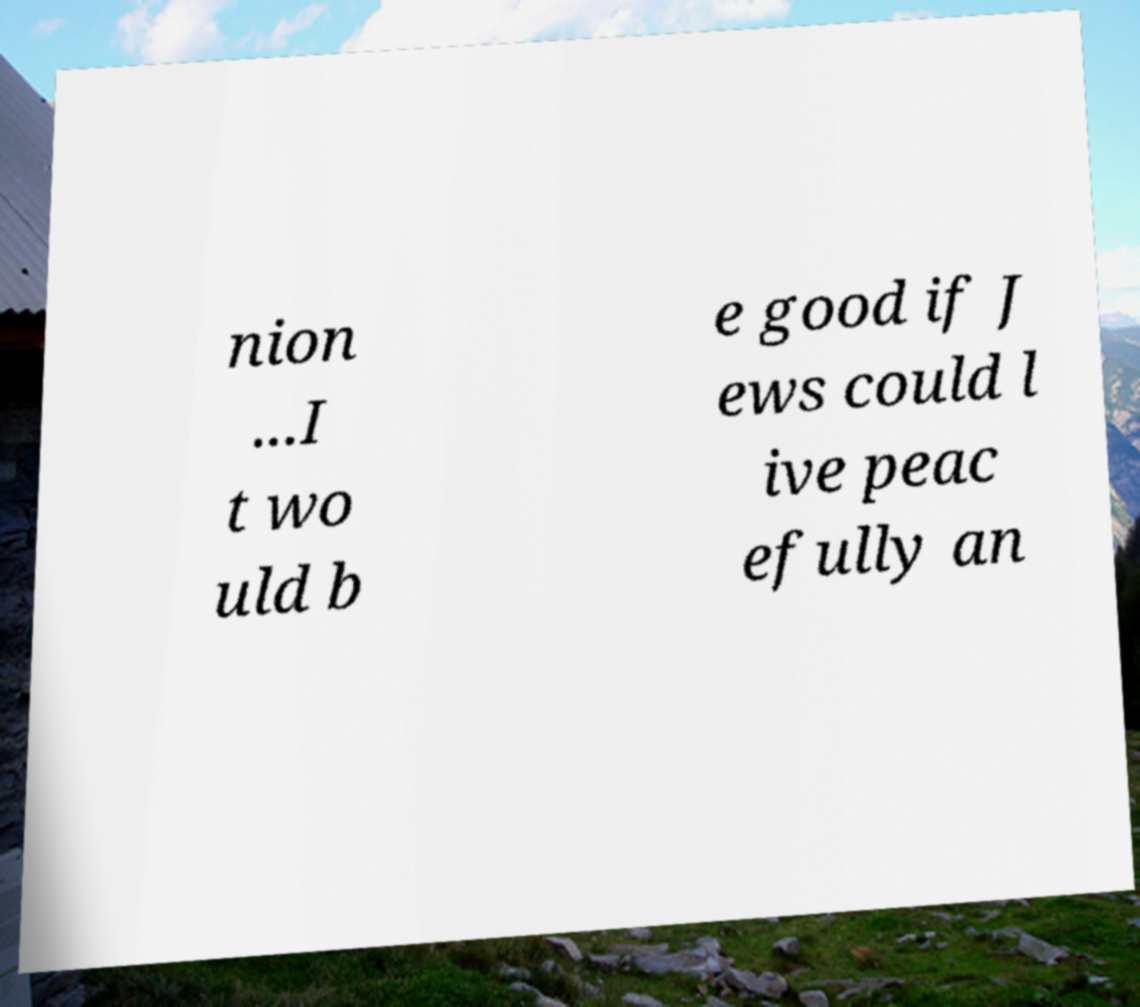Can you accurately transcribe the text from the provided image for me? nion ...I t wo uld b e good if J ews could l ive peac efully an 